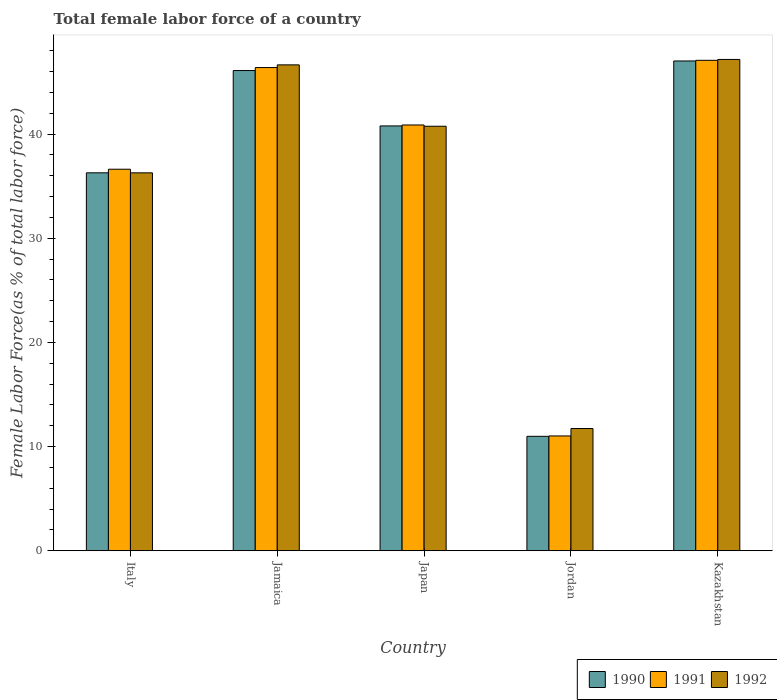How many bars are there on the 3rd tick from the left?
Give a very brief answer. 3. How many bars are there on the 2nd tick from the right?
Keep it short and to the point. 3. What is the label of the 4th group of bars from the left?
Your answer should be compact. Jordan. What is the percentage of female labor force in 1992 in Italy?
Ensure brevity in your answer.  36.29. Across all countries, what is the maximum percentage of female labor force in 1991?
Ensure brevity in your answer.  47.09. Across all countries, what is the minimum percentage of female labor force in 1991?
Offer a very short reply. 11.02. In which country was the percentage of female labor force in 1990 maximum?
Provide a succinct answer. Kazakhstan. In which country was the percentage of female labor force in 1990 minimum?
Ensure brevity in your answer.  Jordan. What is the total percentage of female labor force in 1991 in the graph?
Your response must be concise. 182.03. What is the difference between the percentage of female labor force in 1990 in Jamaica and that in Kazakhstan?
Your answer should be very brief. -0.92. What is the difference between the percentage of female labor force in 1992 in Italy and the percentage of female labor force in 1990 in Japan?
Ensure brevity in your answer.  -4.5. What is the average percentage of female labor force in 1990 per country?
Provide a succinct answer. 36.24. What is the difference between the percentage of female labor force of/in 1992 and percentage of female labor force of/in 1990 in Italy?
Your answer should be compact. -0. What is the ratio of the percentage of female labor force in 1992 in Japan to that in Kazakhstan?
Your answer should be very brief. 0.86. Is the percentage of female labor force in 1990 in Italy less than that in Kazakhstan?
Your response must be concise. Yes. Is the difference between the percentage of female labor force in 1992 in Jamaica and Kazakhstan greater than the difference between the percentage of female labor force in 1990 in Jamaica and Kazakhstan?
Offer a terse response. Yes. What is the difference between the highest and the second highest percentage of female labor force in 1992?
Offer a terse response. -5.89. What is the difference between the highest and the lowest percentage of female labor force in 1991?
Provide a short and direct response. 36.07. What does the 3rd bar from the left in Japan represents?
Offer a very short reply. 1992. What does the 3rd bar from the right in Jamaica represents?
Keep it short and to the point. 1990. Is it the case that in every country, the sum of the percentage of female labor force in 1991 and percentage of female labor force in 1990 is greater than the percentage of female labor force in 1992?
Ensure brevity in your answer.  Yes. What is the difference between two consecutive major ticks on the Y-axis?
Ensure brevity in your answer.  10. Does the graph contain any zero values?
Your response must be concise. No. How are the legend labels stacked?
Your answer should be compact. Horizontal. What is the title of the graph?
Your response must be concise. Total female labor force of a country. What is the label or title of the Y-axis?
Provide a short and direct response. Female Labor Force(as % of total labor force). What is the Female Labor Force(as % of total labor force) in 1990 in Italy?
Provide a succinct answer. 36.29. What is the Female Labor Force(as % of total labor force) of 1991 in Italy?
Your answer should be very brief. 36.63. What is the Female Labor Force(as % of total labor force) of 1992 in Italy?
Ensure brevity in your answer.  36.29. What is the Female Labor Force(as % of total labor force) of 1990 in Jamaica?
Give a very brief answer. 46.11. What is the Female Labor Force(as % of total labor force) in 1991 in Jamaica?
Offer a very short reply. 46.4. What is the Female Labor Force(as % of total labor force) of 1992 in Jamaica?
Your answer should be compact. 46.65. What is the Female Labor Force(as % of total labor force) of 1990 in Japan?
Offer a terse response. 40.79. What is the Female Labor Force(as % of total labor force) of 1991 in Japan?
Your answer should be compact. 40.88. What is the Female Labor Force(as % of total labor force) in 1992 in Japan?
Provide a short and direct response. 40.76. What is the Female Labor Force(as % of total labor force) of 1990 in Jordan?
Give a very brief answer. 10.99. What is the Female Labor Force(as % of total labor force) in 1991 in Jordan?
Ensure brevity in your answer.  11.02. What is the Female Labor Force(as % of total labor force) of 1992 in Jordan?
Provide a short and direct response. 11.73. What is the Female Labor Force(as % of total labor force) of 1990 in Kazakhstan?
Provide a succinct answer. 47.03. What is the Female Labor Force(as % of total labor force) in 1991 in Kazakhstan?
Offer a very short reply. 47.09. What is the Female Labor Force(as % of total labor force) of 1992 in Kazakhstan?
Provide a succinct answer. 47.18. Across all countries, what is the maximum Female Labor Force(as % of total labor force) of 1990?
Your response must be concise. 47.03. Across all countries, what is the maximum Female Labor Force(as % of total labor force) in 1991?
Your answer should be very brief. 47.09. Across all countries, what is the maximum Female Labor Force(as % of total labor force) in 1992?
Your answer should be very brief. 47.18. Across all countries, what is the minimum Female Labor Force(as % of total labor force) of 1990?
Give a very brief answer. 10.99. Across all countries, what is the minimum Female Labor Force(as % of total labor force) of 1991?
Your answer should be compact. 11.02. Across all countries, what is the minimum Female Labor Force(as % of total labor force) of 1992?
Make the answer very short. 11.73. What is the total Female Labor Force(as % of total labor force) in 1990 in the graph?
Offer a very short reply. 181.2. What is the total Female Labor Force(as % of total labor force) in 1991 in the graph?
Make the answer very short. 182.03. What is the total Female Labor Force(as % of total labor force) in 1992 in the graph?
Provide a succinct answer. 182.61. What is the difference between the Female Labor Force(as % of total labor force) of 1990 in Italy and that in Jamaica?
Make the answer very short. -9.82. What is the difference between the Female Labor Force(as % of total labor force) of 1991 in Italy and that in Jamaica?
Offer a terse response. -9.76. What is the difference between the Female Labor Force(as % of total labor force) of 1992 in Italy and that in Jamaica?
Ensure brevity in your answer.  -10.37. What is the difference between the Female Labor Force(as % of total labor force) in 1990 in Italy and that in Japan?
Provide a short and direct response. -4.5. What is the difference between the Female Labor Force(as % of total labor force) of 1991 in Italy and that in Japan?
Your response must be concise. -4.25. What is the difference between the Female Labor Force(as % of total labor force) in 1992 in Italy and that in Japan?
Give a very brief answer. -4.47. What is the difference between the Female Labor Force(as % of total labor force) in 1990 in Italy and that in Jordan?
Your response must be concise. 25.3. What is the difference between the Female Labor Force(as % of total labor force) in 1991 in Italy and that in Jordan?
Ensure brevity in your answer.  25.61. What is the difference between the Female Labor Force(as % of total labor force) of 1992 in Italy and that in Jordan?
Make the answer very short. 24.55. What is the difference between the Female Labor Force(as % of total labor force) of 1990 in Italy and that in Kazakhstan?
Keep it short and to the point. -10.74. What is the difference between the Female Labor Force(as % of total labor force) of 1991 in Italy and that in Kazakhstan?
Your answer should be very brief. -10.46. What is the difference between the Female Labor Force(as % of total labor force) in 1992 in Italy and that in Kazakhstan?
Ensure brevity in your answer.  -10.89. What is the difference between the Female Labor Force(as % of total labor force) of 1990 in Jamaica and that in Japan?
Ensure brevity in your answer.  5.32. What is the difference between the Female Labor Force(as % of total labor force) of 1991 in Jamaica and that in Japan?
Your answer should be very brief. 5.51. What is the difference between the Female Labor Force(as % of total labor force) of 1992 in Jamaica and that in Japan?
Give a very brief answer. 5.89. What is the difference between the Female Labor Force(as % of total labor force) in 1990 in Jamaica and that in Jordan?
Give a very brief answer. 35.12. What is the difference between the Female Labor Force(as % of total labor force) in 1991 in Jamaica and that in Jordan?
Your response must be concise. 35.38. What is the difference between the Female Labor Force(as % of total labor force) of 1992 in Jamaica and that in Jordan?
Give a very brief answer. 34.92. What is the difference between the Female Labor Force(as % of total labor force) of 1990 in Jamaica and that in Kazakhstan?
Make the answer very short. -0.92. What is the difference between the Female Labor Force(as % of total labor force) in 1991 in Jamaica and that in Kazakhstan?
Provide a short and direct response. -0.69. What is the difference between the Female Labor Force(as % of total labor force) in 1992 in Jamaica and that in Kazakhstan?
Keep it short and to the point. -0.52. What is the difference between the Female Labor Force(as % of total labor force) of 1990 in Japan and that in Jordan?
Your answer should be very brief. 29.81. What is the difference between the Female Labor Force(as % of total labor force) of 1991 in Japan and that in Jordan?
Make the answer very short. 29.86. What is the difference between the Female Labor Force(as % of total labor force) of 1992 in Japan and that in Jordan?
Provide a short and direct response. 29.03. What is the difference between the Female Labor Force(as % of total labor force) in 1990 in Japan and that in Kazakhstan?
Keep it short and to the point. -6.24. What is the difference between the Female Labor Force(as % of total labor force) of 1991 in Japan and that in Kazakhstan?
Make the answer very short. -6.21. What is the difference between the Female Labor Force(as % of total labor force) in 1992 in Japan and that in Kazakhstan?
Keep it short and to the point. -6.41. What is the difference between the Female Labor Force(as % of total labor force) of 1990 in Jordan and that in Kazakhstan?
Your answer should be compact. -36.04. What is the difference between the Female Labor Force(as % of total labor force) of 1991 in Jordan and that in Kazakhstan?
Your answer should be compact. -36.07. What is the difference between the Female Labor Force(as % of total labor force) of 1992 in Jordan and that in Kazakhstan?
Your response must be concise. -35.44. What is the difference between the Female Labor Force(as % of total labor force) in 1990 in Italy and the Female Labor Force(as % of total labor force) in 1991 in Jamaica?
Provide a succinct answer. -10.11. What is the difference between the Female Labor Force(as % of total labor force) of 1990 in Italy and the Female Labor Force(as % of total labor force) of 1992 in Jamaica?
Offer a terse response. -10.37. What is the difference between the Female Labor Force(as % of total labor force) of 1991 in Italy and the Female Labor Force(as % of total labor force) of 1992 in Jamaica?
Offer a terse response. -10.02. What is the difference between the Female Labor Force(as % of total labor force) in 1990 in Italy and the Female Labor Force(as % of total labor force) in 1991 in Japan?
Provide a succinct answer. -4.59. What is the difference between the Female Labor Force(as % of total labor force) in 1990 in Italy and the Female Labor Force(as % of total labor force) in 1992 in Japan?
Offer a terse response. -4.47. What is the difference between the Female Labor Force(as % of total labor force) of 1991 in Italy and the Female Labor Force(as % of total labor force) of 1992 in Japan?
Provide a short and direct response. -4.13. What is the difference between the Female Labor Force(as % of total labor force) in 1990 in Italy and the Female Labor Force(as % of total labor force) in 1991 in Jordan?
Give a very brief answer. 25.27. What is the difference between the Female Labor Force(as % of total labor force) of 1990 in Italy and the Female Labor Force(as % of total labor force) of 1992 in Jordan?
Ensure brevity in your answer.  24.55. What is the difference between the Female Labor Force(as % of total labor force) in 1991 in Italy and the Female Labor Force(as % of total labor force) in 1992 in Jordan?
Give a very brief answer. 24.9. What is the difference between the Female Labor Force(as % of total labor force) in 1990 in Italy and the Female Labor Force(as % of total labor force) in 1991 in Kazakhstan?
Your answer should be very brief. -10.8. What is the difference between the Female Labor Force(as % of total labor force) in 1990 in Italy and the Female Labor Force(as % of total labor force) in 1992 in Kazakhstan?
Offer a very short reply. -10.89. What is the difference between the Female Labor Force(as % of total labor force) in 1991 in Italy and the Female Labor Force(as % of total labor force) in 1992 in Kazakhstan?
Ensure brevity in your answer.  -10.54. What is the difference between the Female Labor Force(as % of total labor force) of 1990 in Jamaica and the Female Labor Force(as % of total labor force) of 1991 in Japan?
Provide a succinct answer. 5.23. What is the difference between the Female Labor Force(as % of total labor force) in 1990 in Jamaica and the Female Labor Force(as % of total labor force) in 1992 in Japan?
Make the answer very short. 5.35. What is the difference between the Female Labor Force(as % of total labor force) of 1991 in Jamaica and the Female Labor Force(as % of total labor force) of 1992 in Japan?
Offer a very short reply. 5.64. What is the difference between the Female Labor Force(as % of total labor force) in 1990 in Jamaica and the Female Labor Force(as % of total labor force) in 1991 in Jordan?
Your answer should be very brief. 35.09. What is the difference between the Female Labor Force(as % of total labor force) of 1990 in Jamaica and the Female Labor Force(as % of total labor force) of 1992 in Jordan?
Provide a short and direct response. 34.38. What is the difference between the Female Labor Force(as % of total labor force) of 1991 in Jamaica and the Female Labor Force(as % of total labor force) of 1992 in Jordan?
Provide a succinct answer. 34.66. What is the difference between the Female Labor Force(as % of total labor force) in 1990 in Jamaica and the Female Labor Force(as % of total labor force) in 1991 in Kazakhstan?
Give a very brief answer. -0.98. What is the difference between the Female Labor Force(as % of total labor force) in 1990 in Jamaica and the Female Labor Force(as % of total labor force) in 1992 in Kazakhstan?
Provide a short and direct response. -1.07. What is the difference between the Female Labor Force(as % of total labor force) in 1991 in Jamaica and the Female Labor Force(as % of total labor force) in 1992 in Kazakhstan?
Your answer should be very brief. -0.78. What is the difference between the Female Labor Force(as % of total labor force) in 1990 in Japan and the Female Labor Force(as % of total labor force) in 1991 in Jordan?
Make the answer very short. 29.77. What is the difference between the Female Labor Force(as % of total labor force) of 1990 in Japan and the Female Labor Force(as % of total labor force) of 1992 in Jordan?
Give a very brief answer. 29.06. What is the difference between the Female Labor Force(as % of total labor force) in 1991 in Japan and the Female Labor Force(as % of total labor force) in 1992 in Jordan?
Offer a very short reply. 29.15. What is the difference between the Female Labor Force(as % of total labor force) in 1990 in Japan and the Female Labor Force(as % of total labor force) in 1991 in Kazakhstan?
Provide a short and direct response. -6.3. What is the difference between the Female Labor Force(as % of total labor force) in 1990 in Japan and the Female Labor Force(as % of total labor force) in 1992 in Kazakhstan?
Provide a short and direct response. -6.39. What is the difference between the Female Labor Force(as % of total labor force) in 1991 in Japan and the Female Labor Force(as % of total labor force) in 1992 in Kazakhstan?
Your answer should be compact. -6.29. What is the difference between the Female Labor Force(as % of total labor force) of 1990 in Jordan and the Female Labor Force(as % of total labor force) of 1991 in Kazakhstan?
Provide a succinct answer. -36.11. What is the difference between the Female Labor Force(as % of total labor force) in 1990 in Jordan and the Female Labor Force(as % of total labor force) in 1992 in Kazakhstan?
Your answer should be very brief. -36.19. What is the difference between the Female Labor Force(as % of total labor force) in 1991 in Jordan and the Female Labor Force(as % of total labor force) in 1992 in Kazakhstan?
Ensure brevity in your answer.  -36.15. What is the average Female Labor Force(as % of total labor force) of 1990 per country?
Make the answer very short. 36.24. What is the average Female Labor Force(as % of total labor force) in 1991 per country?
Offer a very short reply. 36.41. What is the average Female Labor Force(as % of total labor force) in 1992 per country?
Offer a very short reply. 36.52. What is the difference between the Female Labor Force(as % of total labor force) in 1990 and Female Labor Force(as % of total labor force) in 1991 in Italy?
Offer a terse response. -0.34. What is the difference between the Female Labor Force(as % of total labor force) of 1990 and Female Labor Force(as % of total labor force) of 1992 in Italy?
Provide a short and direct response. 0. What is the difference between the Female Labor Force(as % of total labor force) in 1991 and Female Labor Force(as % of total labor force) in 1992 in Italy?
Provide a short and direct response. 0.35. What is the difference between the Female Labor Force(as % of total labor force) in 1990 and Female Labor Force(as % of total labor force) in 1991 in Jamaica?
Keep it short and to the point. -0.29. What is the difference between the Female Labor Force(as % of total labor force) in 1990 and Female Labor Force(as % of total labor force) in 1992 in Jamaica?
Provide a short and direct response. -0.54. What is the difference between the Female Labor Force(as % of total labor force) of 1991 and Female Labor Force(as % of total labor force) of 1992 in Jamaica?
Give a very brief answer. -0.26. What is the difference between the Female Labor Force(as % of total labor force) of 1990 and Female Labor Force(as % of total labor force) of 1991 in Japan?
Provide a short and direct response. -0.09. What is the difference between the Female Labor Force(as % of total labor force) of 1990 and Female Labor Force(as % of total labor force) of 1992 in Japan?
Provide a short and direct response. 0.03. What is the difference between the Female Labor Force(as % of total labor force) of 1991 and Female Labor Force(as % of total labor force) of 1992 in Japan?
Ensure brevity in your answer.  0.12. What is the difference between the Female Labor Force(as % of total labor force) of 1990 and Female Labor Force(as % of total labor force) of 1991 in Jordan?
Give a very brief answer. -0.04. What is the difference between the Female Labor Force(as % of total labor force) in 1990 and Female Labor Force(as % of total labor force) in 1992 in Jordan?
Offer a terse response. -0.75. What is the difference between the Female Labor Force(as % of total labor force) of 1991 and Female Labor Force(as % of total labor force) of 1992 in Jordan?
Keep it short and to the point. -0.71. What is the difference between the Female Labor Force(as % of total labor force) in 1990 and Female Labor Force(as % of total labor force) in 1991 in Kazakhstan?
Your answer should be compact. -0.06. What is the difference between the Female Labor Force(as % of total labor force) of 1990 and Female Labor Force(as % of total labor force) of 1992 in Kazakhstan?
Offer a terse response. -0.15. What is the difference between the Female Labor Force(as % of total labor force) of 1991 and Female Labor Force(as % of total labor force) of 1992 in Kazakhstan?
Offer a very short reply. -0.08. What is the ratio of the Female Labor Force(as % of total labor force) of 1990 in Italy to that in Jamaica?
Your response must be concise. 0.79. What is the ratio of the Female Labor Force(as % of total labor force) in 1991 in Italy to that in Jamaica?
Your response must be concise. 0.79. What is the ratio of the Female Labor Force(as % of total labor force) of 1990 in Italy to that in Japan?
Ensure brevity in your answer.  0.89. What is the ratio of the Female Labor Force(as % of total labor force) of 1991 in Italy to that in Japan?
Offer a terse response. 0.9. What is the ratio of the Female Labor Force(as % of total labor force) in 1992 in Italy to that in Japan?
Keep it short and to the point. 0.89. What is the ratio of the Female Labor Force(as % of total labor force) in 1990 in Italy to that in Jordan?
Provide a succinct answer. 3.3. What is the ratio of the Female Labor Force(as % of total labor force) of 1991 in Italy to that in Jordan?
Your response must be concise. 3.32. What is the ratio of the Female Labor Force(as % of total labor force) of 1992 in Italy to that in Jordan?
Offer a very short reply. 3.09. What is the ratio of the Female Labor Force(as % of total labor force) in 1990 in Italy to that in Kazakhstan?
Keep it short and to the point. 0.77. What is the ratio of the Female Labor Force(as % of total labor force) of 1991 in Italy to that in Kazakhstan?
Offer a very short reply. 0.78. What is the ratio of the Female Labor Force(as % of total labor force) in 1992 in Italy to that in Kazakhstan?
Your answer should be compact. 0.77. What is the ratio of the Female Labor Force(as % of total labor force) in 1990 in Jamaica to that in Japan?
Keep it short and to the point. 1.13. What is the ratio of the Female Labor Force(as % of total labor force) in 1991 in Jamaica to that in Japan?
Ensure brevity in your answer.  1.13. What is the ratio of the Female Labor Force(as % of total labor force) in 1992 in Jamaica to that in Japan?
Give a very brief answer. 1.14. What is the ratio of the Female Labor Force(as % of total labor force) in 1990 in Jamaica to that in Jordan?
Provide a succinct answer. 4.2. What is the ratio of the Female Labor Force(as % of total labor force) in 1991 in Jamaica to that in Jordan?
Ensure brevity in your answer.  4.21. What is the ratio of the Female Labor Force(as % of total labor force) of 1992 in Jamaica to that in Jordan?
Your answer should be very brief. 3.98. What is the ratio of the Female Labor Force(as % of total labor force) of 1990 in Jamaica to that in Kazakhstan?
Give a very brief answer. 0.98. What is the ratio of the Female Labor Force(as % of total labor force) in 1991 in Jamaica to that in Kazakhstan?
Offer a terse response. 0.99. What is the ratio of the Female Labor Force(as % of total labor force) of 1992 in Jamaica to that in Kazakhstan?
Give a very brief answer. 0.99. What is the ratio of the Female Labor Force(as % of total labor force) of 1990 in Japan to that in Jordan?
Make the answer very short. 3.71. What is the ratio of the Female Labor Force(as % of total labor force) of 1991 in Japan to that in Jordan?
Your answer should be compact. 3.71. What is the ratio of the Female Labor Force(as % of total labor force) of 1992 in Japan to that in Jordan?
Your answer should be compact. 3.47. What is the ratio of the Female Labor Force(as % of total labor force) of 1990 in Japan to that in Kazakhstan?
Your answer should be very brief. 0.87. What is the ratio of the Female Labor Force(as % of total labor force) in 1991 in Japan to that in Kazakhstan?
Make the answer very short. 0.87. What is the ratio of the Female Labor Force(as % of total labor force) in 1992 in Japan to that in Kazakhstan?
Your answer should be very brief. 0.86. What is the ratio of the Female Labor Force(as % of total labor force) of 1990 in Jordan to that in Kazakhstan?
Offer a terse response. 0.23. What is the ratio of the Female Labor Force(as % of total labor force) of 1991 in Jordan to that in Kazakhstan?
Make the answer very short. 0.23. What is the ratio of the Female Labor Force(as % of total labor force) of 1992 in Jordan to that in Kazakhstan?
Give a very brief answer. 0.25. What is the difference between the highest and the second highest Female Labor Force(as % of total labor force) in 1990?
Keep it short and to the point. 0.92. What is the difference between the highest and the second highest Female Labor Force(as % of total labor force) in 1991?
Offer a terse response. 0.69. What is the difference between the highest and the second highest Female Labor Force(as % of total labor force) in 1992?
Provide a short and direct response. 0.52. What is the difference between the highest and the lowest Female Labor Force(as % of total labor force) in 1990?
Your answer should be compact. 36.04. What is the difference between the highest and the lowest Female Labor Force(as % of total labor force) of 1991?
Make the answer very short. 36.07. What is the difference between the highest and the lowest Female Labor Force(as % of total labor force) of 1992?
Your answer should be very brief. 35.44. 